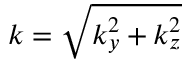Convert formula to latex. <formula><loc_0><loc_0><loc_500><loc_500>k = \sqrt { k _ { y } ^ { 2 } + k _ { z } ^ { 2 } }</formula> 